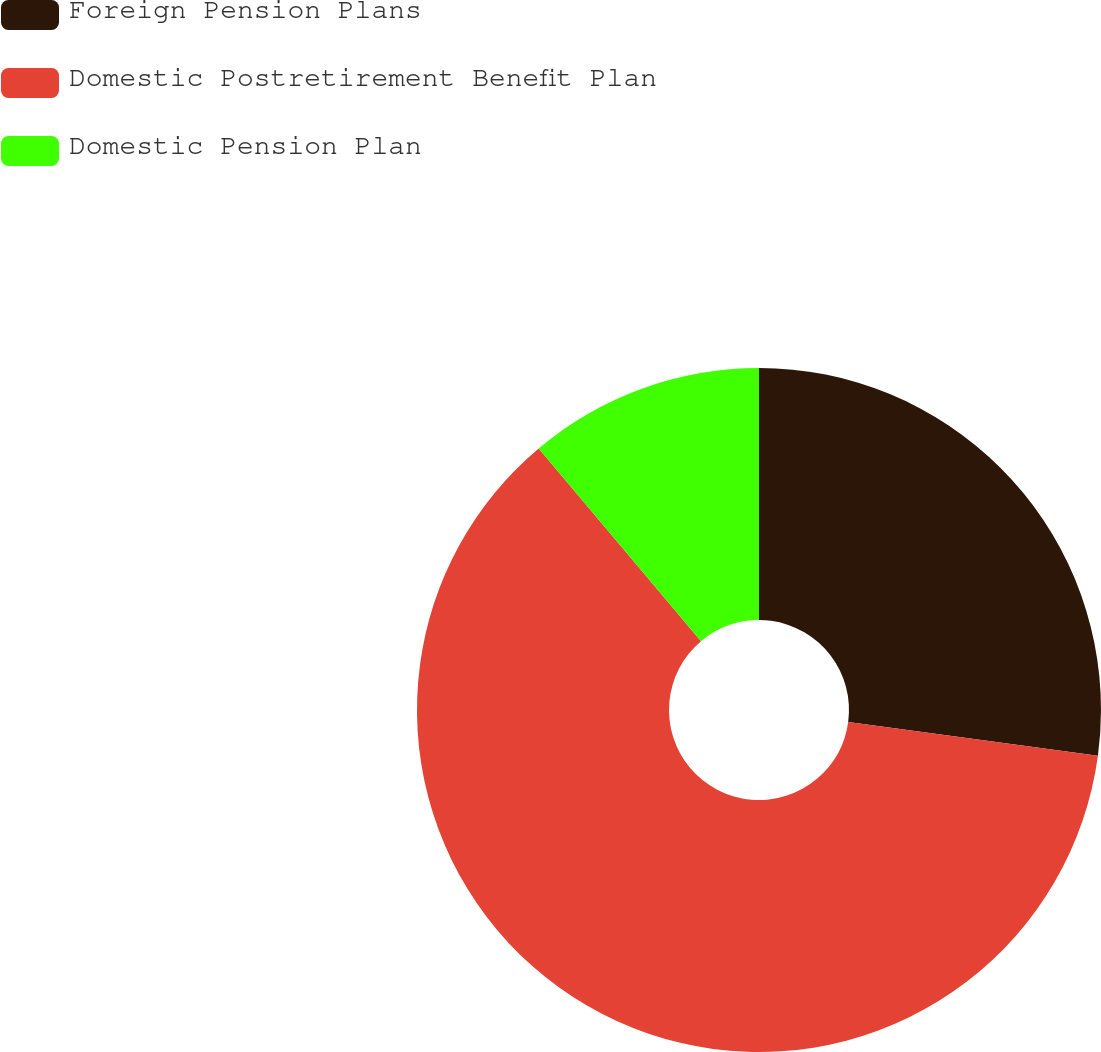<chart> <loc_0><loc_0><loc_500><loc_500><pie_chart><fcel>Foreign Pension Plans<fcel>Domestic Postretirement Benefit Plan<fcel>Domestic Pension Plan<nl><fcel>27.14%<fcel>61.72%<fcel>11.14%<nl></chart> 